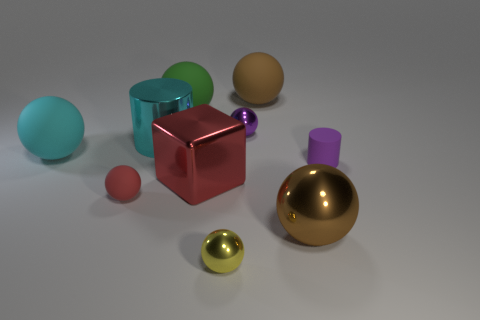How many big red things are there?
Offer a very short reply. 1. How many things are metal cylinders or big purple metallic balls?
Give a very brief answer. 1. What number of big brown rubber balls are behind the tiny matte thing that is right of the cyan thing on the right side of the big cyan matte thing?
Give a very brief answer. 1. Are there any other things that have the same color as the metallic cube?
Your response must be concise. Yes. Do the matte sphere in front of the tiny matte cylinder and the block that is to the right of the small red rubber thing have the same color?
Make the answer very short. Yes. Are there more tiny cylinders left of the small purple rubber thing than tiny red balls in front of the large brown metal ball?
Your answer should be very brief. No. What material is the purple cylinder?
Provide a succinct answer. Rubber. The small shiny thing behind the large shiny object right of the big brown ball that is behind the cyan matte object is what shape?
Ensure brevity in your answer.  Sphere. Do the large brown object that is in front of the purple metallic object and the large cylinder that is behind the shiny block have the same material?
Offer a terse response. Yes. How many matte objects are both in front of the big brown rubber thing and behind the small purple cylinder?
Your answer should be compact. 2. 